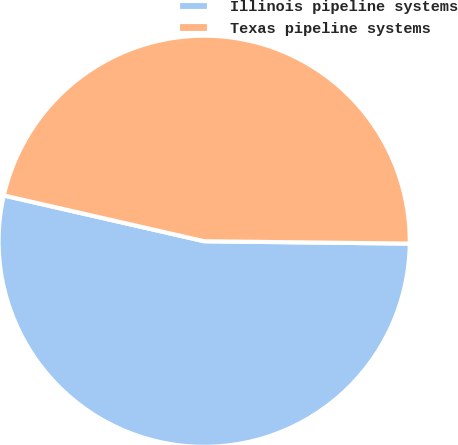Convert chart to OTSL. <chart><loc_0><loc_0><loc_500><loc_500><pie_chart><fcel>Illinois pipeline systems<fcel>Texas pipeline systems<nl><fcel>53.39%<fcel>46.61%<nl></chart> 